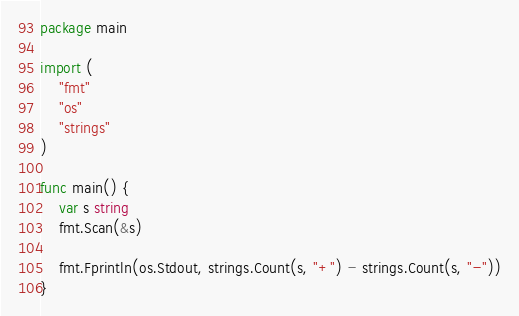Convert code to text. <code><loc_0><loc_0><loc_500><loc_500><_Go_>package main

import (
    "fmt"
    "os"
    "strings"
)

func main() {
    var s string
    fmt.Scan(&s)

    fmt.Fprintln(os.Stdout, strings.Count(s, "+") - strings.Count(s, "-"))
}</code> 